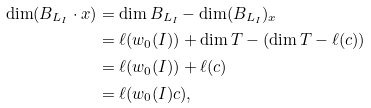Convert formula to latex. <formula><loc_0><loc_0><loc_500><loc_500>\dim ( B _ { L _ { I } } \cdot x ) & = \dim B _ { L _ { I } } - \dim ( B _ { L _ { I } } ) _ { x } \\ & = \ell ( w _ { 0 } ( I ) ) + \dim T - ( \dim T - \ell ( c ) ) \\ & = \ell ( w _ { 0 } ( I ) ) + \ell ( c ) \\ & = \ell ( w _ { 0 } ( I ) c ) ,</formula> 